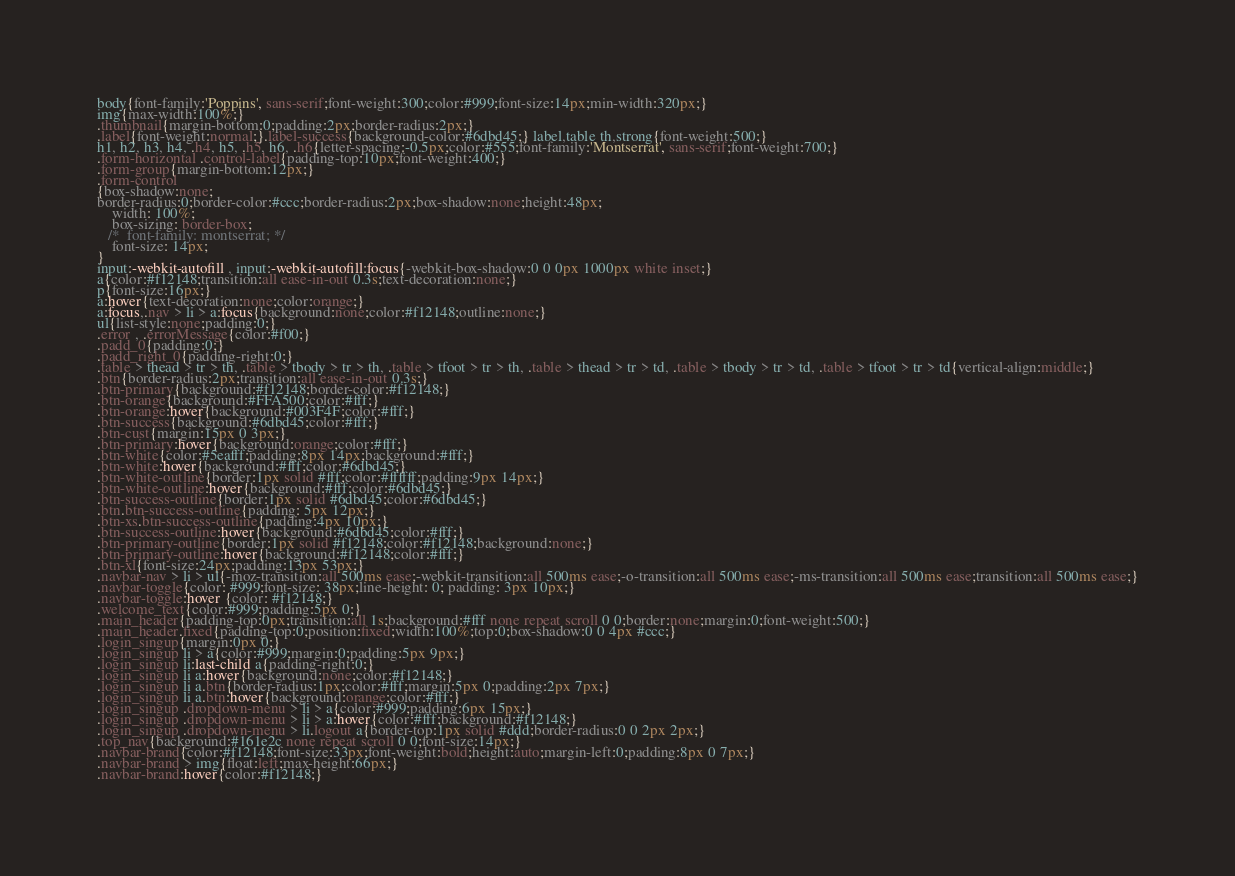Convert code to text. <code><loc_0><loc_0><loc_500><loc_500><_CSS_>body{font-family:'Poppins', sans-serif;font-weight:300;color:#999;font-size:14px;min-width:320px;}
img{max-width:100%;}
.thumbnail{margin-bottom:0;padding:2px;border-radius:2px;}
.label{font-weight:normal;}.label-success{background-color:#6dbd45;} label,table th,strong{font-weight:500;}
h1, h2, h3, h4, .h4, h5, .h5, h6, .h6{letter-spacing:-0.5px;color:#555;font-family:'Montserrat', sans-serif;font-weight:700;}
.form-horizontal .control-label{padding-top:10px;font-weight:400;}
.form-group{margin-bottom:12px;}
.form-control
{box-shadow:none;
border-radius:0;border-color:#ccc;border-radius:2px;box-shadow:none;height:48px;
    width: 100%;
    box-sizing: border-box;
   /*  font-family: montserrat; */
    font-size: 14px;
}
input:-webkit-autofill , input:-webkit-autofill:focus{-webkit-box-shadow:0 0 0px 1000px white inset;}
a{color:#f12148;transition:all ease-in-out 0.3s;text-decoration:none;}
p{font-size:16px;}
a:hover{text-decoration:none;color:orange;}
a:focus,.nav > li > a:focus{background:none;color:#f12148;outline:none;}
ul{list-style:none;padding:0;}
.error , .errorMessage{color:#f00;}
.padd_0{padding:0;}
.padd_right_0{padding-right:0;}
.table > thead > tr > th, .table > tbody > tr > th, .table > tfoot > tr > th, .table > thead > tr > td, .table > tbody > tr > td, .table > tfoot > tr > td{vertical-align:middle;}
.btn{border-radius:2px;transition:all ease-in-out 0.3s;}
.btn-primary{background:#f12148;border-color:#f12148;}
.btn-orange{background:#FFA500;color:#fff;}
.btn-orange:hover{background:#003F4F;color:#fff;}
.btn-success{background:#6dbd45;color:#fff;}
.btn-cust{margin:15px 0 3px;}
.btn-primary:hover{background:orange;color:#fff;}
.btn-white{color:#5eafff;padding:8px 14px;background:#fff;}
.btn-white:hover{background:#fff;color:#6dbd45;}
.btn-white-outline{border:1px solid #fff;color:#ffffff;padding:9px 14px;}
.btn-white-outline:hover{background:#fff;color:#6dbd45;}
.btn-success-outline{border:1px solid #6dbd45;color:#6dbd45;}
.btn.btn-success-outline{padding: 5px 12px;}
.btn-xs.btn-success-outline{padding:4px 10px;}
.btn-success-outline:hover{background:#6dbd45;color:#fff;}
.btn-primary-outline{border:1px solid #f12148;color:#f12148;background:none;}
.btn-primary-outline:hover{background:#f12148;color:#fff;}
.btn-xl{font-size:24px;padding:13px 53px;}
.navbar-nav > li > ul{-moz-transition:all 500ms ease;-webkit-transition:all 500ms ease;-o-transition:all 500ms ease;-ms-transition:all 500ms ease;transition:all 500ms ease;}
.navbar-toggle{color: #999;font-size: 38px;line-height: 0; padding: 3px 10px;}
.navbar-toggle:hover {color: #f12148;}
.welcome_text{color:#999;padding:5px 0;}
.main_header{padding-top:0px;transition:all 1s;background:#fff none repeat scroll 0 0;border:none;margin:0;font-weight:500;}
.main_header.fixed{padding-top:0;position:fixed;width:100%;top:0;box-shadow:0 0 4px #ccc;}
.login_singup{margin:0px 0;}
.login_singup li > a{color:#999;margin:0;padding:5px 9px;}
.login_singup li:last-child a{padding-right:0;} 
.login_singup li a:hover{background:none;color:#f12148;}
.login_singup li a.btn{border-radius:1px;color:#fff;margin:5px 0;padding:2px 7px;}
.login_singup li a.btn:hover{background:orange;color:#fff;}
.login_singup .dropdown-menu > li > a{color:#999;padding:6px 15px;}
.login_singup .dropdown-menu > li > a:hover{color:#fff;background:#f12148;}
.login_singup .dropdown-menu > li.logout a{border-top:1px solid #ddd;border-radius:0 0 2px 2px;}
.top_nav{background:#161e2c none repeat scroll 0 0;font-size:14px;}
.navbar-brand{color:#f12148;font-size:33px;font-weight:bold;height:auto;margin-left:0;padding:8px 0 7px;}
.navbar-brand > img{float:left;max-height:66px;}
.navbar-brand:hover{color:#f12148;}</code> 